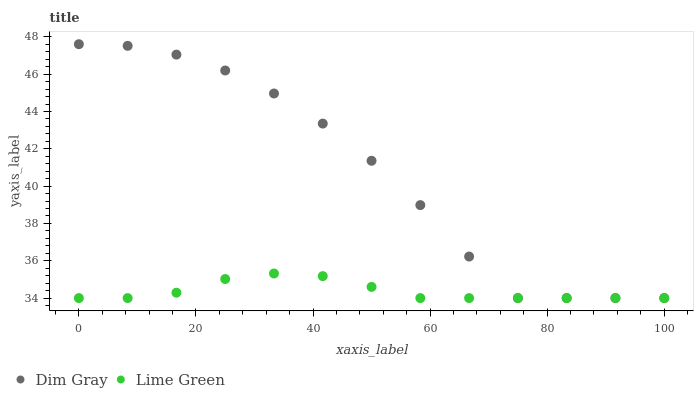Does Lime Green have the minimum area under the curve?
Answer yes or no. Yes. Does Dim Gray have the maximum area under the curve?
Answer yes or no. Yes. Does Lime Green have the maximum area under the curve?
Answer yes or no. No. Is Lime Green the smoothest?
Answer yes or no. Yes. Is Dim Gray the roughest?
Answer yes or no. Yes. Is Lime Green the roughest?
Answer yes or no. No. Does Dim Gray have the lowest value?
Answer yes or no. Yes. Does Dim Gray have the highest value?
Answer yes or no. Yes. Does Lime Green have the highest value?
Answer yes or no. No. Does Lime Green intersect Dim Gray?
Answer yes or no. Yes. Is Lime Green less than Dim Gray?
Answer yes or no. No. Is Lime Green greater than Dim Gray?
Answer yes or no. No. 